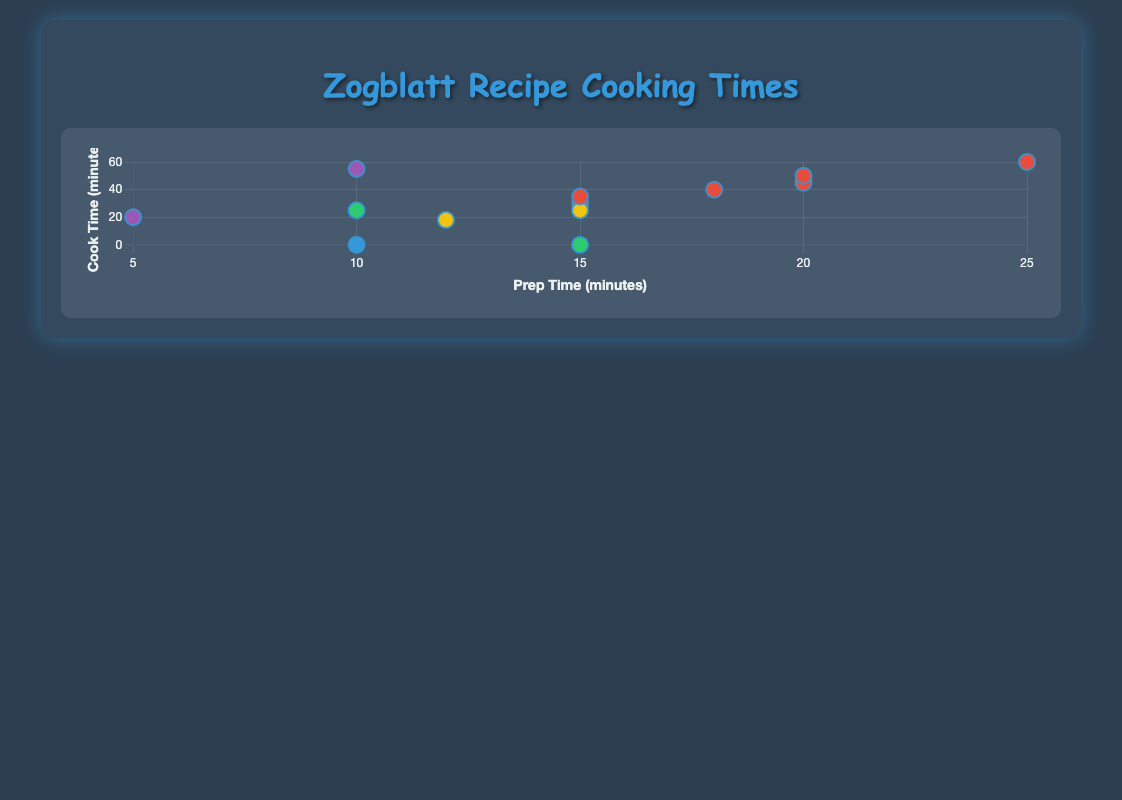How many recipes take less than 10 minutes to prepare? From the figure, only one recipe, "Zogblatt Elfin Glaze," has a prep time of 5 minutes, which is less than 10 minutes.
Answer: 1 Which recipe has the longest cooking time? "Zogblatt Spicy Glaxt Loaf" has a cooking time of 60 minutes, which is the longest in the figure.
Answer: Zogblatt Spicy Glaxt Loaf What is the average cooking time for Main Course recipes? First, identify all Main Course recipes: "Zogblatt Honey-Spiced Tumsht" (45), "Zogblatt Fire-Grilled Lorb" (30), "Zogblatt Spicy Glaxt Loaf" (60), "Zogblatt Herb-Encrusted Blore" (40), "Zogblatt Purblet Stew" (50), "Zogblatt Dulcet Grillt" (35). Sum their cooking times: 45 + 30 + 60 + 40 + 50 + 35 = 260. Divide by the number of recipes: 260 / 6 ≈ 43.3.
Answer: 43.3 Which category has the highest average prep time? Compute the average prep time for each category:
- Main Course: (20 + 15 + 25 + 18 + 20 + 15) / 6 = 18.83
- Salad: 10 / 1 = 10
- Dessert: (15 + 12) / 2 = 13.5
- Appetizer: (10 + 15) / 2 = 12.5
- Condiment: (10 + 5) / 2 = 7.5
Answer: Main Course Is there any recipe that doesn't require cooking? The plot shows two recipes with a cook time of 0 minutes: "Zogblatt Juar Fruit Salad" and "Zogblatt Marinated Zuff."
Answer: Yes, two recipes Which dessert has the shortest overall preparation and cooking time? Compare total times for desserts:
- "Zogblatt Glimberry Tart": 15 + 25 = 40
- "Zogblatt Zint Cookies": 12 + 18 = 30
"Zogblatt Zint Cookies" has the shortest time of 30 minutes.
Answer: Zogblatt Zint Cookies What's the difference in cook time between "Zogblatt Purblet Stew" and "Zogblatt Theshberry Jam"? "Zogblatt Purblet Stew" has a cook time of 50 minutes, and "Zogblatt Theshberry Jam" has a cook time of 55 minutes. The difference is 55 - 50 = 5 minutes.
Answer: 5 minutes How many recipes have a prep time of exactly 15 minutes? Five recipes have a prep time of exactly 15 minutes: "Zogblatt Fire-Grilled Lorb," "Zogblatt Glimberry Tart," "Zogblatt Marinated Zuff," "Zogblatt Dulcet Grillt," and "Zogblatt Spicy Glaxt Loaf."
Answer: 5 Which recipe has the shortest cooking time for an appetizer? Compare the cooking times for appetizers:
- "Zogblatt Chebroot Soup": 25 minutes
- "Zogblatt Marinated Zuff": 0 minutes
"Zogblatt Marinated Zuff" is the shortest.
Answer: Zogblatt Marinated Zuff Given the scatter plot, which category is visually represented in green? Cross-referencing the color and category information, the color green corresponds to the "Appetizer" category.
Answer: Appetizer 